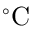<formula> <loc_0><loc_0><loc_500><loc_500>^ { \circ } C</formula> 